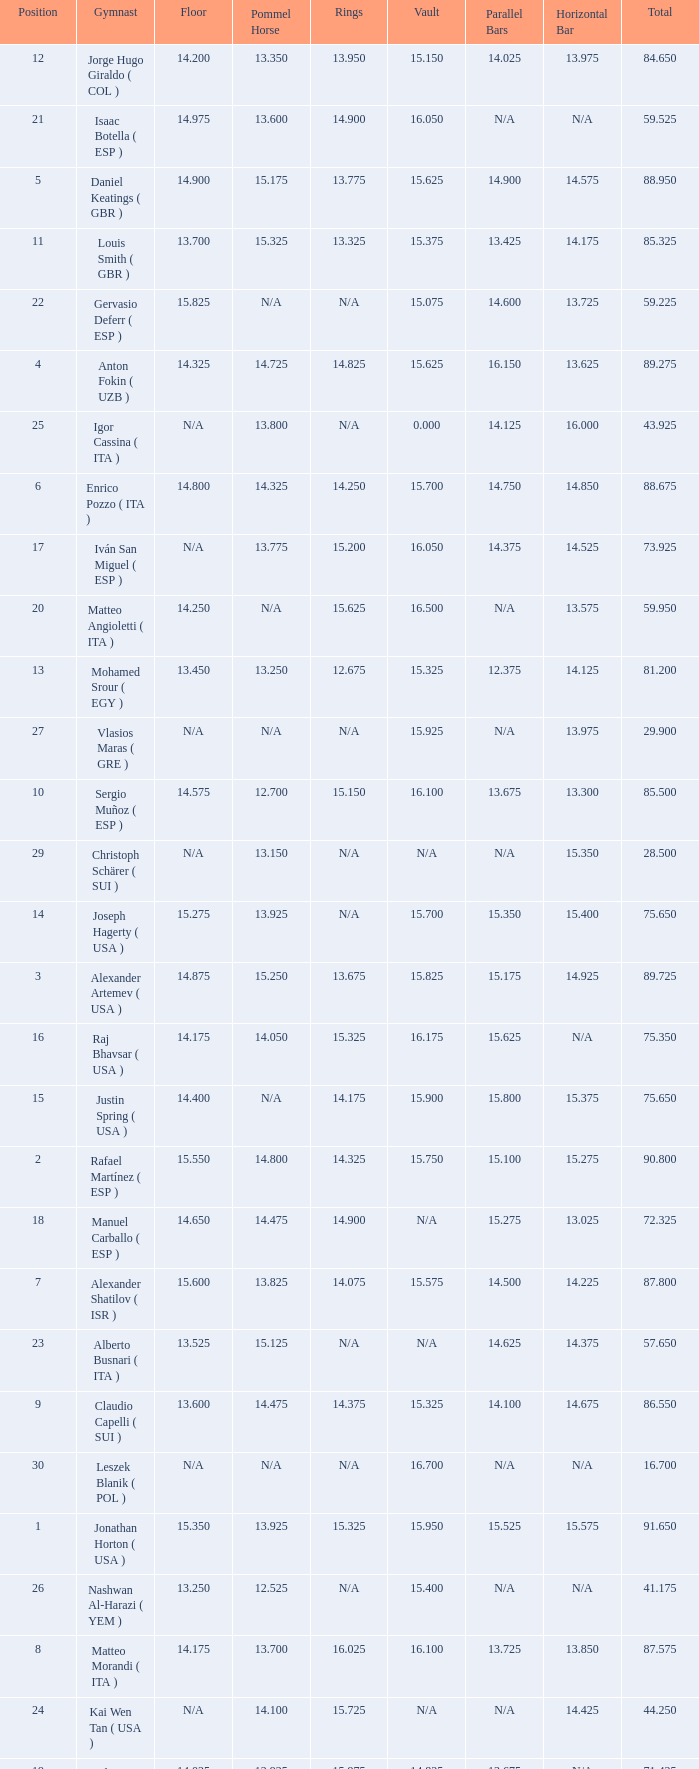If the parallel bars is 14.025, what is the total number of gymnasts? 1.0. 